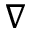Convert formula to latex. <formula><loc_0><loc_0><loc_500><loc_500>\nabla</formula> 